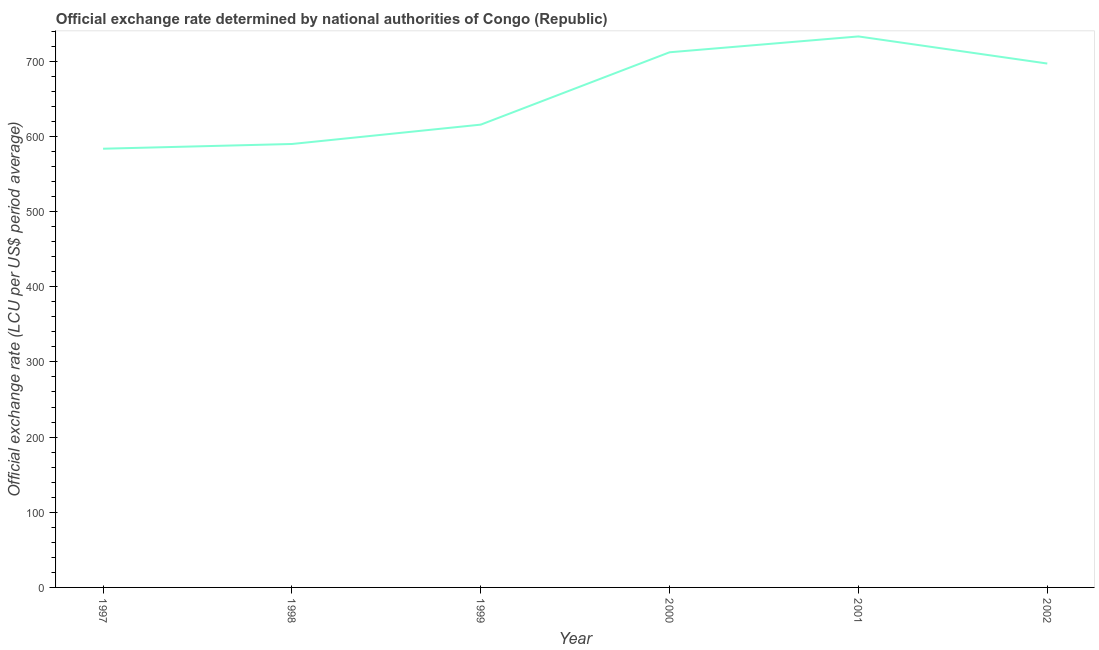What is the official exchange rate in 2002?
Provide a succinct answer. 696.99. Across all years, what is the maximum official exchange rate?
Give a very brief answer. 733.04. Across all years, what is the minimum official exchange rate?
Offer a very short reply. 583.67. What is the sum of the official exchange rate?
Ensure brevity in your answer.  3931.32. What is the difference between the official exchange rate in 1998 and 2002?
Your response must be concise. -107.04. What is the average official exchange rate per year?
Make the answer very short. 655.22. What is the median official exchange rate?
Your response must be concise. 656.34. What is the ratio of the official exchange rate in 1998 to that in 1999?
Keep it short and to the point. 0.96. Is the difference between the official exchange rate in 2000 and 2001 greater than the difference between any two years?
Give a very brief answer. No. What is the difference between the highest and the second highest official exchange rate?
Your answer should be very brief. 21.06. What is the difference between the highest and the lowest official exchange rate?
Ensure brevity in your answer.  149.37. Does the graph contain grids?
Make the answer very short. No. What is the title of the graph?
Your answer should be compact. Official exchange rate determined by national authorities of Congo (Republic). What is the label or title of the X-axis?
Offer a terse response. Year. What is the label or title of the Y-axis?
Offer a terse response. Official exchange rate (LCU per US$ period average). What is the Official exchange rate (LCU per US$ period average) in 1997?
Your answer should be compact. 583.67. What is the Official exchange rate (LCU per US$ period average) in 1998?
Your response must be concise. 589.95. What is the Official exchange rate (LCU per US$ period average) in 1999?
Your response must be concise. 615.7. What is the Official exchange rate (LCU per US$ period average) of 2000?
Ensure brevity in your answer.  711.98. What is the Official exchange rate (LCU per US$ period average) in 2001?
Make the answer very short. 733.04. What is the Official exchange rate (LCU per US$ period average) of 2002?
Your answer should be compact. 696.99. What is the difference between the Official exchange rate (LCU per US$ period average) in 1997 and 1998?
Ensure brevity in your answer.  -6.28. What is the difference between the Official exchange rate (LCU per US$ period average) in 1997 and 1999?
Keep it short and to the point. -32.03. What is the difference between the Official exchange rate (LCU per US$ period average) in 1997 and 2000?
Provide a short and direct response. -128.31. What is the difference between the Official exchange rate (LCU per US$ period average) in 1997 and 2001?
Keep it short and to the point. -149.37. What is the difference between the Official exchange rate (LCU per US$ period average) in 1997 and 2002?
Offer a very short reply. -113.32. What is the difference between the Official exchange rate (LCU per US$ period average) in 1998 and 1999?
Offer a terse response. -25.75. What is the difference between the Official exchange rate (LCU per US$ period average) in 1998 and 2000?
Offer a terse response. -122.02. What is the difference between the Official exchange rate (LCU per US$ period average) in 1998 and 2001?
Provide a short and direct response. -143.09. What is the difference between the Official exchange rate (LCU per US$ period average) in 1998 and 2002?
Give a very brief answer. -107.04. What is the difference between the Official exchange rate (LCU per US$ period average) in 1999 and 2000?
Give a very brief answer. -96.28. What is the difference between the Official exchange rate (LCU per US$ period average) in 1999 and 2001?
Your response must be concise. -117.34. What is the difference between the Official exchange rate (LCU per US$ period average) in 1999 and 2002?
Give a very brief answer. -81.29. What is the difference between the Official exchange rate (LCU per US$ period average) in 2000 and 2001?
Provide a succinct answer. -21.06. What is the difference between the Official exchange rate (LCU per US$ period average) in 2000 and 2002?
Make the answer very short. 14.99. What is the difference between the Official exchange rate (LCU per US$ period average) in 2001 and 2002?
Offer a very short reply. 36.05. What is the ratio of the Official exchange rate (LCU per US$ period average) in 1997 to that in 1999?
Your response must be concise. 0.95. What is the ratio of the Official exchange rate (LCU per US$ period average) in 1997 to that in 2000?
Provide a succinct answer. 0.82. What is the ratio of the Official exchange rate (LCU per US$ period average) in 1997 to that in 2001?
Provide a succinct answer. 0.8. What is the ratio of the Official exchange rate (LCU per US$ period average) in 1997 to that in 2002?
Your response must be concise. 0.84. What is the ratio of the Official exchange rate (LCU per US$ period average) in 1998 to that in 1999?
Make the answer very short. 0.96. What is the ratio of the Official exchange rate (LCU per US$ period average) in 1998 to that in 2000?
Your answer should be very brief. 0.83. What is the ratio of the Official exchange rate (LCU per US$ period average) in 1998 to that in 2001?
Provide a succinct answer. 0.81. What is the ratio of the Official exchange rate (LCU per US$ period average) in 1998 to that in 2002?
Keep it short and to the point. 0.85. What is the ratio of the Official exchange rate (LCU per US$ period average) in 1999 to that in 2000?
Ensure brevity in your answer.  0.86. What is the ratio of the Official exchange rate (LCU per US$ period average) in 1999 to that in 2001?
Ensure brevity in your answer.  0.84. What is the ratio of the Official exchange rate (LCU per US$ period average) in 1999 to that in 2002?
Provide a short and direct response. 0.88. What is the ratio of the Official exchange rate (LCU per US$ period average) in 2000 to that in 2001?
Give a very brief answer. 0.97. What is the ratio of the Official exchange rate (LCU per US$ period average) in 2000 to that in 2002?
Keep it short and to the point. 1.02. What is the ratio of the Official exchange rate (LCU per US$ period average) in 2001 to that in 2002?
Make the answer very short. 1.05. 